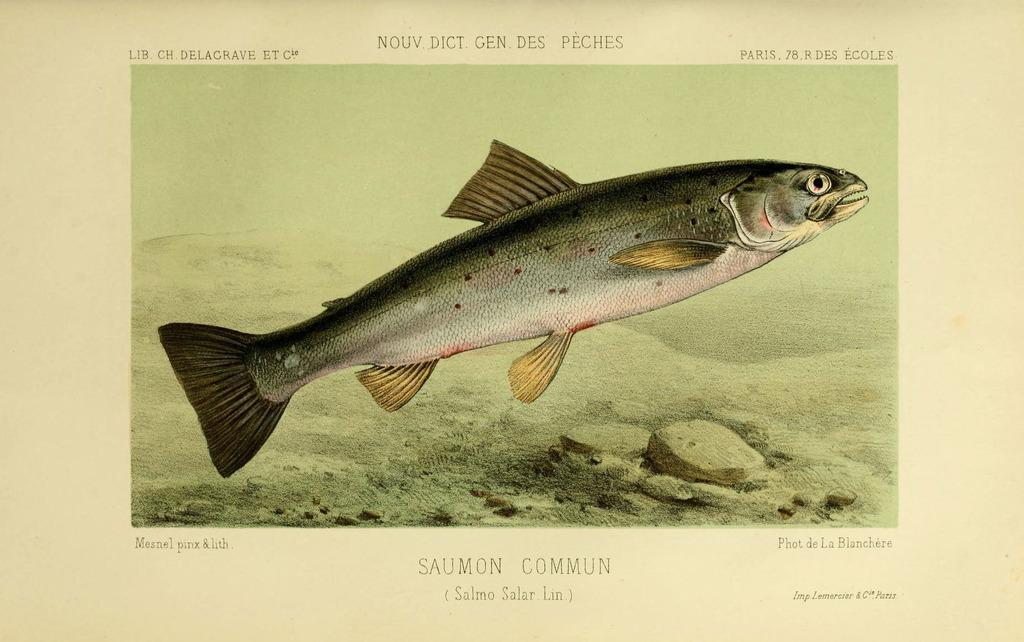What type of animal is in the image? There is a fish in the image. What color is the fish? The fish is gray in color. What else can be seen in the image besides the fish? There are stones visible in the image. Is there any text or writing present in the image? Yes, there is text or writing present in the image. Reasoning: Let' Let's think step by step in order to produce the conversation. We start by identifying the main subject in the image, which is the fish. Then, we describe the color of the fish to provide more detail. Next, we mention the presence of stones in the image to give context to the fish's environment. Finally, we acknowledge the presence of text or writing in the image, which may provide additional information or context. Absurd Question/Answer: What type of temper does the fish exhibit in the image? There is no indication of the fish's temper in the image, as it is a still image and does not show any emotions or behaviors. 